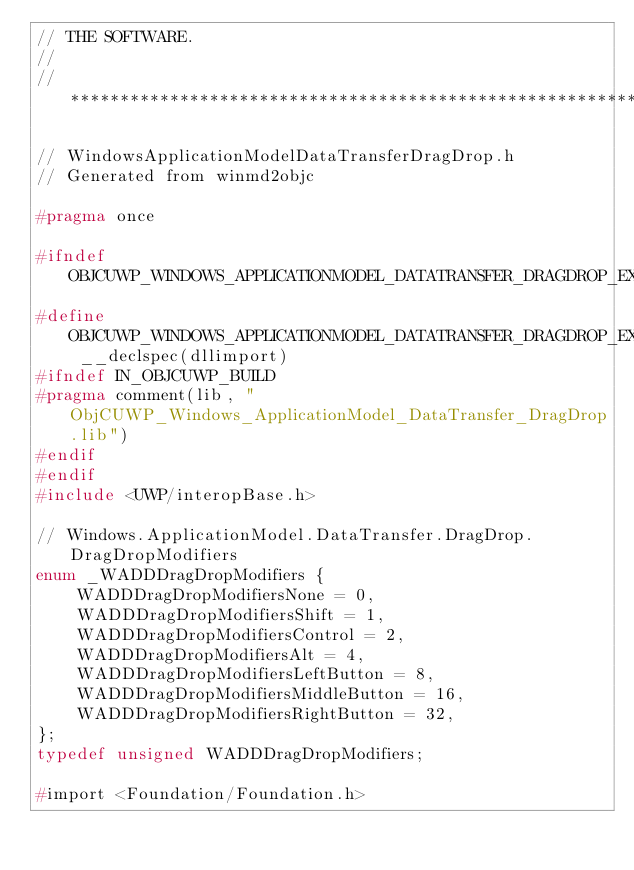<code> <loc_0><loc_0><loc_500><loc_500><_C_>// THE SOFTWARE.
//
//******************************************************************************

// WindowsApplicationModelDataTransferDragDrop.h
// Generated from winmd2objc

#pragma once

#ifndef OBJCUWP_WINDOWS_APPLICATIONMODEL_DATATRANSFER_DRAGDROP_EXPORT
#define OBJCUWP_WINDOWS_APPLICATIONMODEL_DATATRANSFER_DRAGDROP_EXPORT __declspec(dllimport)
#ifndef IN_OBJCUWP_BUILD
#pragma comment(lib, "ObjCUWP_Windows_ApplicationModel_DataTransfer_DragDrop.lib")
#endif
#endif
#include <UWP/interopBase.h>

// Windows.ApplicationModel.DataTransfer.DragDrop.DragDropModifiers
enum _WADDDragDropModifiers {
    WADDDragDropModifiersNone = 0,
    WADDDragDropModifiersShift = 1,
    WADDDragDropModifiersControl = 2,
    WADDDragDropModifiersAlt = 4,
    WADDDragDropModifiersLeftButton = 8,
    WADDDragDropModifiersMiddleButton = 16,
    WADDDragDropModifiersRightButton = 32,
};
typedef unsigned WADDDragDropModifiers;

#import <Foundation/Foundation.h>

</code> 